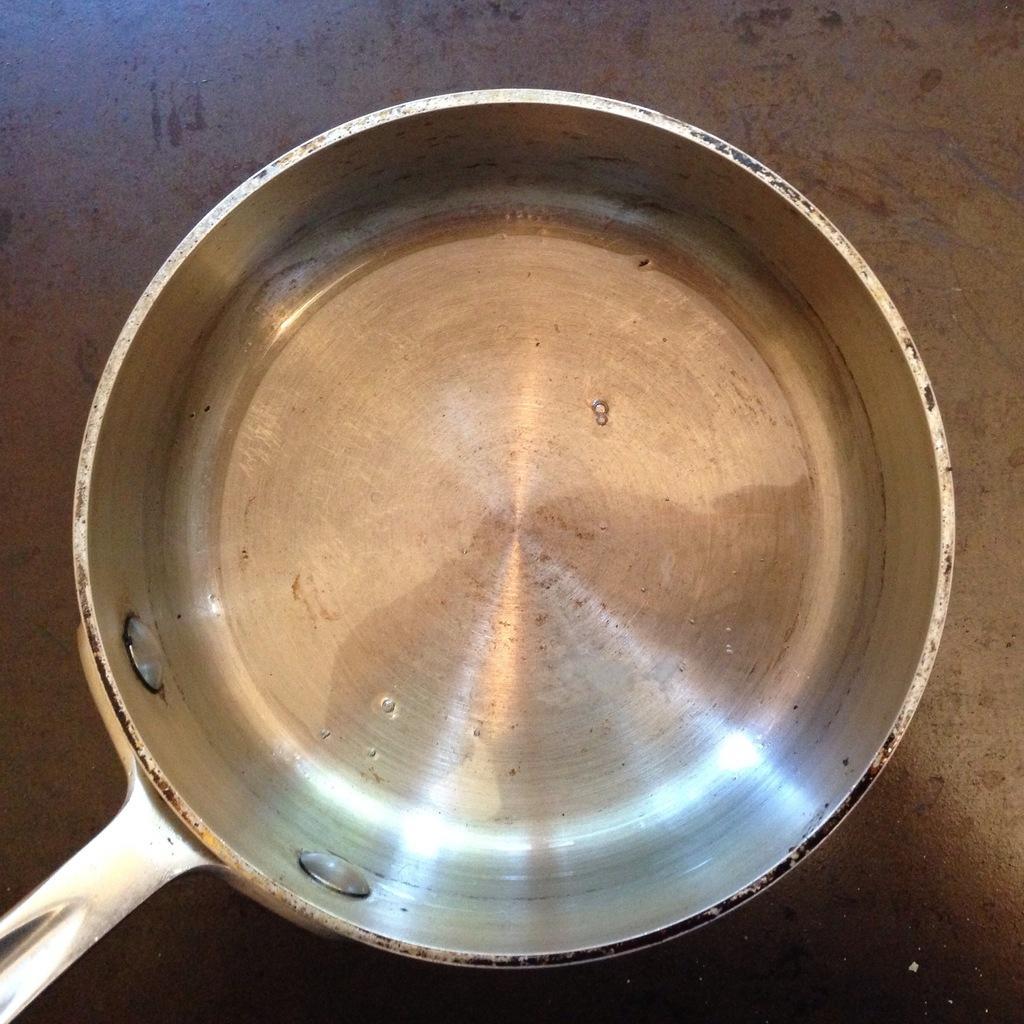Please provide a concise description of this image. In this image there is a pan on the floor. 